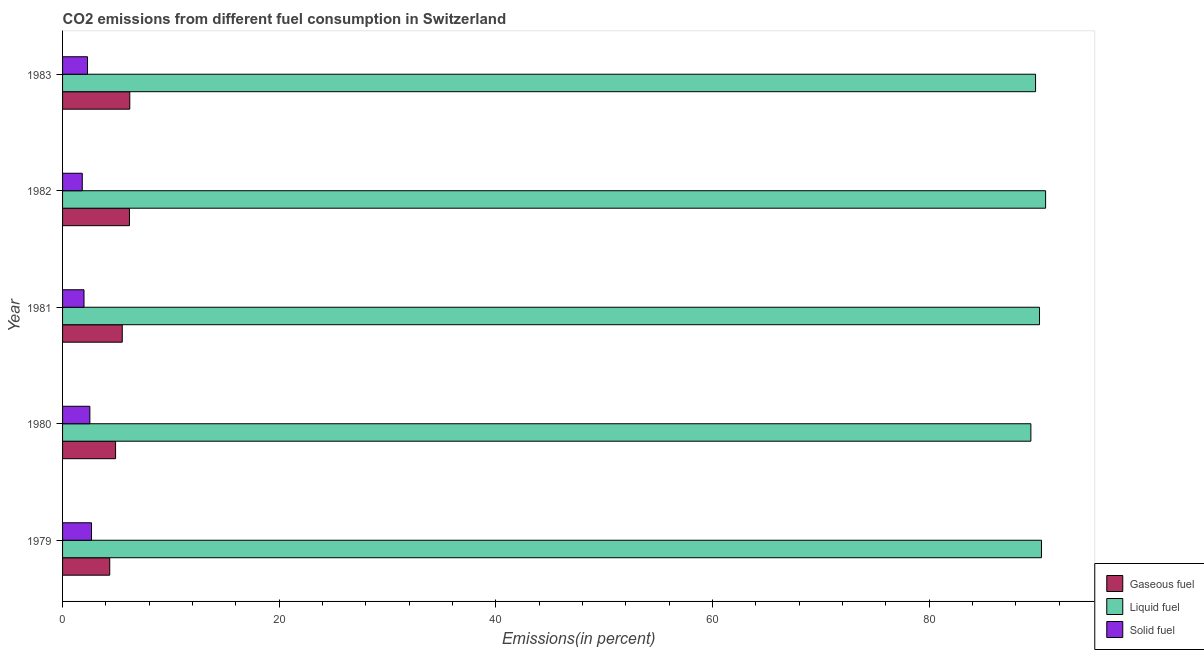Are the number of bars per tick equal to the number of legend labels?
Offer a very short reply. Yes. Are the number of bars on each tick of the Y-axis equal?
Keep it short and to the point. Yes. How many bars are there on the 1st tick from the top?
Ensure brevity in your answer.  3. What is the label of the 2nd group of bars from the top?
Provide a succinct answer. 1982. In how many cases, is the number of bars for a given year not equal to the number of legend labels?
Ensure brevity in your answer.  0. What is the percentage of gaseous fuel emission in 1979?
Your answer should be very brief. 4.36. Across all years, what is the maximum percentage of solid fuel emission?
Provide a short and direct response. 2.67. Across all years, what is the minimum percentage of solid fuel emission?
Provide a short and direct response. 1.82. In which year was the percentage of solid fuel emission maximum?
Your answer should be very brief. 1979. In which year was the percentage of gaseous fuel emission minimum?
Your answer should be very brief. 1979. What is the total percentage of solid fuel emission in the graph?
Provide a succinct answer. 11.29. What is the difference between the percentage of gaseous fuel emission in 1979 and that in 1983?
Give a very brief answer. -1.85. What is the difference between the percentage of liquid fuel emission in 1982 and the percentage of gaseous fuel emission in 1981?
Provide a succinct answer. 85.24. What is the average percentage of liquid fuel emission per year?
Offer a terse response. 90.11. In the year 1982, what is the difference between the percentage of liquid fuel emission and percentage of gaseous fuel emission?
Ensure brevity in your answer.  84.58. In how many years, is the percentage of gaseous fuel emission greater than 88 %?
Your answer should be very brief. 0. Is the difference between the percentage of gaseous fuel emission in 1981 and 1982 greater than the difference between the percentage of liquid fuel emission in 1981 and 1982?
Your response must be concise. No. What is the difference between the highest and the second highest percentage of gaseous fuel emission?
Offer a very short reply. 0.03. What is the difference between the highest and the lowest percentage of gaseous fuel emission?
Give a very brief answer. 1.85. Is the sum of the percentage of liquid fuel emission in 1981 and 1983 greater than the maximum percentage of solid fuel emission across all years?
Offer a terse response. Yes. What does the 1st bar from the top in 1983 represents?
Provide a succinct answer. Solid fuel. What does the 3rd bar from the bottom in 1983 represents?
Provide a short and direct response. Solid fuel. Is it the case that in every year, the sum of the percentage of gaseous fuel emission and percentage of liquid fuel emission is greater than the percentage of solid fuel emission?
Offer a very short reply. Yes. How many bars are there?
Provide a short and direct response. 15. Are all the bars in the graph horizontal?
Offer a very short reply. Yes. Does the graph contain grids?
Provide a succinct answer. No. How many legend labels are there?
Give a very brief answer. 3. What is the title of the graph?
Make the answer very short. CO2 emissions from different fuel consumption in Switzerland. What is the label or title of the X-axis?
Provide a short and direct response. Emissions(in percent). What is the Emissions(in percent) in Gaseous fuel in 1979?
Your answer should be compact. 4.36. What is the Emissions(in percent) in Liquid fuel in 1979?
Your answer should be compact. 90.37. What is the Emissions(in percent) in Solid fuel in 1979?
Your response must be concise. 2.67. What is the Emissions(in percent) of Gaseous fuel in 1980?
Provide a succinct answer. 4.89. What is the Emissions(in percent) in Liquid fuel in 1980?
Make the answer very short. 89.39. What is the Emissions(in percent) in Solid fuel in 1980?
Your response must be concise. 2.52. What is the Emissions(in percent) of Gaseous fuel in 1981?
Provide a succinct answer. 5.51. What is the Emissions(in percent) in Liquid fuel in 1981?
Give a very brief answer. 90.19. What is the Emissions(in percent) of Solid fuel in 1981?
Ensure brevity in your answer.  1.98. What is the Emissions(in percent) in Gaseous fuel in 1982?
Offer a terse response. 6.18. What is the Emissions(in percent) of Liquid fuel in 1982?
Ensure brevity in your answer.  90.75. What is the Emissions(in percent) in Solid fuel in 1982?
Provide a short and direct response. 1.82. What is the Emissions(in percent) in Gaseous fuel in 1983?
Your answer should be compact. 6.2. What is the Emissions(in percent) of Liquid fuel in 1983?
Your answer should be very brief. 89.83. What is the Emissions(in percent) of Solid fuel in 1983?
Keep it short and to the point. 2.3. Across all years, what is the maximum Emissions(in percent) of Gaseous fuel?
Offer a very short reply. 6.2. Across all years, what is the maximum Emissions(in percent) in Liquid fuel?
Provide a short and direct response. 90.75. Across all years, what is the maximum Emissions(in percent) in Solid fuel?
Offer a terse response. 2.67. Across all years, what is the minimum Emissions(in percent) of Gaseous fuel?
Keep it short and to the point. 4.36. Across all years, what is the minimum Emissions(in percent) in Liquid fuel?
Provide a succinct answer. 89.39. Across all years, what is the minimum Emissions(in percent) of Solid fuel?
Provide a succinct answer. 1.82. What is the total Emissions(in percent) in Gaseous fuel in the graph?
Give a very brief answer. 27.14. What is the total Emissions(in percent) in Liquid fuel in the graph?
Ensure brevity in your answer.  450.53. What is the total Emissions(in percent) in Solid fuel in the graph?
Offer a very short reply. 11.29. What is the difference between the Emissions(in percent) in Gaseous fuel in 1979 and that in 1980?
Offer a terse response. -0.54. What is the difference between the Emissions(in percent) in Liquid fuel in 1979 and that in 1980?
Provide a succinct answer. 0.98. What is the difference between the Emissions(in percent) of Solid fuel in 1979 and that in 1980?
Keep it short and to the point. 0.15. What is the difference between the Emissions(in percent) of Gaseous fuel in 1979 and that in 1981?
Your answer should be very brief. -1.16. What is the difference between the Emissions(in percent) in Liquid fuel in 1979 and that in 1981?
Offer a very short reply. 0.18. What is the difference between the Emissions(in percent) of Solid fuel in 1979 and that in 1981?
Provide a short and direct response. 0.69. What is the difference between the Emissions(in percent) of Gaseous fuel in 1979 and that in 1982?
Make the answer very short. -1.82. What is the difference between the Emissions(in percent) in Liquid fuel in 1979 and that in 1982?
Offer a terse response. -0.38. What is the difference between the Emissions(in percent) in Solid fuel in 1979 and that in 1982?
Ensure brevity in your answer.  0.85. What is the difference between the Emissions(in percent) of Gaseous fuel in 1979 and that in 1983?
Provide a short and direct response. -1.85. What is the difference between the Emissions(in percent) of Liquid fuel in 1979 and that in 1983?
Your response must be concise. 0.54. What is the difference between the Emissions(in percent) of Solid fuel in 1979 and that in 1983?
Ensure brevity in your answer.  0.37. What is the difference between the Emissions(in percent) in Gaseous fuel in 1980 and that in 1981?
Your answer should be very brief. -0.62. What is the difference between the Emissions(in percent) in Liquid fuel in 1980 and that in 1981?
Your answer should be compact. -0.8. What is the difference between the Emissions(in percent) of Solid fuel in 1980 and that in 1981?
Keep it short and to the point. 0.54. What is the difference between the Emissions(in percent) in Gaseous fuel in 1980 and that in 1982?
Offer a very short reply. -1.28. What is the difference between the Emissions(in percent) of Liquid fuel in 1980 and that in 1982?
Keep it short and to the point. -1.36. What is the difference between the Emissions(in percent) of Solid fuel in 1980 and that in 1982?
Offer a very short reply. 0.7. What is the difference between the Emissions(in percent) in Gaseous fuel in 1980 and that in 1983?
Your answer should be compact. -1.31. What is the difference between the Emissions(in percent) in Liquid fuel in 1980 and that in 1983?
Offer a terse response. -0.43. What is the difference between the Emissions(in percent) in Solid fuel in 1980 and that in 1983?
Your answer should be compact. 0.22. What is the difference between the Emissions(in percent) of Gaseous fuel in 1981 and that in 1982?
Make the answer very short. -0.67. What is the difference between the Emissions(in percent) in Liquid fuel in 1981 and that in 1982?
Provide a succinct answer. -0.56. What is the difference between the Emissions(in percent) in Solid fuel in 1981 and that in 1982?
Offer a terse response. 0.16. What is the difference between the Emissions(in percent) of Gaseous fuel in 1981 and that in 1983?
Your answer should be very brief. -0.69. What is the difference between the Emissions(in percent) of Liquid fuel in 1981 and that in 1983?
Your answer should be very brief. 0.36. What is the difference between the Emissions(in percent) of Solid fuel in 1981 and that in 1983?
Your answer should be compact. -0.32. What is the difference between the Emissions(in percent) in Gaseous fuel in 1982 and that in 1983?
Give a very brief answer. -0.03. What is the difference between the Emissions(in percent) of Liquid fuel in 1982 and that in 1983?
Keep it short and to the point. 0.93. What is the difference between the Emissions(in percent) of Solid fuel in 1982 and that in 1983?
Offer a terse response. -0.48. What is the difference between the Emissions(in percent) in Gaseous fuel in 1979 and the Emissions(in percent) in Liquid fuel in 1980?
Give a very brief answer. -85.04. What is the difference between the Emissions(in percent) of Gaseous fuel in 1979 and the Emissions(in percent) of Solid fuel in 1980?
Ensure brevity in your answer.  1.84. What is the difference between the Emissions(in percent) of Liquid fuel in 1979 and the Emissions(in percent) of Solid fuel in 1980?
Offer a very short reply. 87.85. What is the difference between the Emissions(in percent) in Gaseous fuel in 1979 and the Emissions(in percent) in Liquid fuel in 1981?
Your response must be concise. -85.83. What is the difference between the Emissions(in percent) in Gaseous fuel in 1979 and the Emissions(in percent) in Solid fuel in 1981?
Your response must be concise. 2.38. What is the difference between the Emissions(in percent) of Liquid fuel in 1979 and the Emissions(in percent) of Solid fuel in 1981?
Ensure brevity in your answer.  88.39. What is the difference between the Emissions(in percent) in Gaseous fuel in 1979 and the Emissions(in percent) in Liquid fuel in 1982?
Provide a succinct answer. -86.4. What is the difference between the Emissions(in percent) of Gaseous fuel in 1979 and the Emissions(in percent) of Solid fuel in 1982?
Ensure brevity in your answer.  2.53. What is the difference between the Emissions(in percent) in Liquid fuel in 1979 and the Emissions(in percent) in Solid fuel in 1982?
Make the answer very short. 88.55. What is the difference between the Emissions(in percent) in Gaseous fuel in 1979 and the Emissions(in percent) in Liquid fuel in 1983?
Provide a succinct answer. -85.47. What is the difference between the Emissions(in percent) of Gaseous fuel in 1979 and the Emissions(in percent) of Solid fuel in 1983?
Offer a terse response. 2.05. What is the difference between the Emissions(in percent) of Liquid fuel in 1979 and the Emissions(in percent) of Solid fuel in 1983?
Provide a short and direct response. 88.07. What is the difference between the Emissions(in percent) of Gaseous fuel in 1980 and the Emissions(in percent) of Liquid fuel in 1981?
Offer a very short reply. -85.3. What is the difference between the Emissions(in percent) in Gaseous fuel in 1980 and the Emissions(in percent) in Solid fuel in 1981?
Your answer should be very brief. 2.91. What is the difference between the Emissions(in percent) in Liquid fuel in 1980 and the Emissions(in percent) in Solid fuel in 1981?
Keep it short and to the point. 87.41. What is the difference between the Emissions(in percent) in Gaseous fuel in 1980 and the Emissions(in percent) in Liquid fuel in 1982?
Provide a succinct answer. -85.86. What is the difference between the Emissions(in percent) in Gaseous fuel in 1980 and the Emissions(in percent) in Solid fuel in 1982?
Provide a succinct answer. 3.07. What is the difference between the Emissions(in percent) in Liquid fuel in 1980 and the Emissions(in percent) in Solid fuel in 1982?
Offer a terse response. 87.57. What is the difference between the Emissions(in percent) of Gaseous fuel in 1980 and the Emissions(in percent) of Liquid fuel in 1983?
Keep it short and to the point. -84.93. What is the difference between the Emissions(in percent) in Gaseous fuel in 1980 and the Emissions(in percent) in Solid fuel in 1983?
Offer a very short reply. 2.59. What is the difference between the Emissions(in percent) of Liquid fuel in 1980 and the Emissions(in percent) of Solid fuel in 1983?
Provide a succinct answer. 87.09. What is the difference between the Emissions(in percent) of Gaseous fuel in 1981 and the Emissions(in percent) of Liquid fuel in 1982?
Provide a short and direct response. -85.24. What is the difference between the Emissions(in percent) in Gaseous fuel in 1981 and the Emissions(in percent) in Solid fuel in 1982?
Your response must be concise. 3.69. What is the difference between the Emissions(in percent) in Liquid fuel in 1981 and the Emissions(in percent) in Solid fuel in 1982?
Keep it short and to the point. 88.37. What is the difference between the Emissions(in percent) in Gaseous fuel in 1981 and the Emissions(in percent) in Liquid fuel in 1983?
Your response must be concise. -84.31. What is the difference between the Emissions(in percent) in Gaseous fuel in 1981 and the Emissions(in percent) in Solid fuel in 1983?
Your response must be concise. 3.21. What is the difference between the Emissions(in percent) of Liquid fuel in 1981 and the Emissions(in percent) of Solid fuel in 1983?
Give a very brief answer. 87.89. What is the difference between the Emissions(in percent) of Gaseous fuel in 1982 and the Emissions(in percent) of Liquid fuel in 1983?
Provide a succinct answer. -83.65. What is the difference between the Emissions(in percent) in Gaseous fuel in 1982 and the Emissions(in percent) in Solid fuel in 1983?
Offer a very short reply. 3.87. What is the difference between the Emissions(in percent) of Liquid fuel in 1982 and the Emissions(in percent) of Solid fuel in 1983?
Keep it short and to the point. 88.45. What is the average Emissions(in percent) in Gaseous fuel per year?
Provide a short and direct response. 5.43. What is the average Emissions(in percent) of Liquid fuel per year?
Provide a short and direct response. 90.11. What is the average Emissions(in percent) in Solid fuel per year?
Your answer should be compact. 2.26. In the year 1979, what is the difference between the Emissions(in percent) in Gaseous fuel and Emissions(in percent) in Liquid fuel?
Provide a short and direct response. -86.01. In the year 1979, what is the difference between the Emissions(in percent) of Gaseous fuel and Emissions(in percent) of Solid fuel?
Provide a short and direct response. 1.68. In the year 1979, what is the difference between the Emissions(in percent) of Liquid fuel and Emissions(in percent) of Solid fuel?
Provide a short and direct response. 87.7. In the year 1980, what is the difference between the Emissions(in percent) in Gaseous fuel and Emissions(in percent) in Liquid fuel?
Your answer should be very brief. -84.5. In the year 1980, what is the difference between the Emissions(in percent) in Gaseous fuel and Emissions(in percent) in Solid fuel?
Make the answer very short. 2.37. In the year 1980, what is the difference between the Emissions(in percent) of Liquid fuel and Emissions(in percent) of Solid fuel?
Your response must be concise. 86.87. In the year 1981, what is the difference between the Emissions(in percent) of Gaseous fuel and Emissions(in percent) of Liquid fuel?
Offer a terse response. -84.68. In the year 1981, what is the difference between the Emissions(in percent) of Gaseous fuel and Emissions(in percent) of Solid fuel?
Give a very brief answer. 3.53. In the year 1981, what is the difference between the Emissions(in percent) in Liquid fuel and Emissions(in percent) in Solid fuel?
Make the answer very short. 88.21. In the year 1982, what is the difference between the Emissions(in percent) of Gaseous fuel and Emissions(in percent) of Liquid fuel?
Provide a succinct answer. -84.58. In the year 1982, what is the difference between the Emissions(in percent) of Gaseous fuel and Emissions(in percent) of Solid fuel?
Your answer should be very brief. 4.36. In the year 1982, what is the difference between the Emissions(in percent) in Liquid fuel and Emissions(in percent) in Solid fuel?
Provide a short and direct response. 88.93. In the year 1983, what is the difference between the Emissions(in percent) in Gaseous fuel and Emissions(in percent) in Liquid fuel?
Your answer should be very brief. -83.62. In the year 1983, what is the difference between the Emissions(in percent) of Gaseous fuel and Emissions(in percent) of Solid fuel?
Your response must be concise. 3.9. In the year 1983, what is the difference between the Emissions(in percent) of Liquid fuel and Emissions(in percent) of Solid fuel?
Give a very brief answer. 87.52. What is the ratio of the Emissions(in percent) of Gaseous fuel in 1979 to that in 1980?
Your response must be concise. 0.89. What is the ratio of the Emissions(in percent) in Liquid fuel in 1979 to that in 1980?
Your answer should be very brief. 1.01. What is the ratio of the Emissions(in percent) of Solid fuel in 1979 to that in 1980?
Provide a succinct answer. 1.06. What is the ratio of the Emissions(in percent) of Gaseous fuel in 1979 to that in 1981?
Provide a short and direct response. 0.79. What is the ratio of the Emissions(in percent) of Solid fuel in 1979 to that in 1981?
Your response must be concise. 1.35. What is the ratio of the Emissions(in percent) in Gaseous fuel in 1979 to that in 1982?
Make the answer very short. 0.71. What is the ratio of the Emissions(in percent) of Liquid fuel in 1979 to that in 1982?
Offer a very short reply. 1. What is the ratio of the Emissions(in percent) in Solid fuel in 1979 to that in 1982?
Offer a very short reply. 1.47. What is the ratio of the Emissions(in percent) of Gaseous fuel in 1979 to that in 1983?
Make the answer very short. 0.7. What is the ratio of the Emissions(in percent) in Liquid fuel in 1979 to that in 1983?
Your answer should be very brief. 1.01. What is the ratio of the Emissions(in percent) of Solid fuel in 1979 to that in 1983?
Keep it short and to the point. 1.16. What is the ratio of the Emissions(in percent) of Gaseous fuel in 1980 to that in 1981?
Make the answer very short. 0.89. What is the ratio of the Emissions(in percent) of Solid fuel in 1980 to that in 1981?
Make the answer very short. 1.27. What is the ratio of the Emissions(in percent) in Gaseous fuel in 1980 to that in 1982?
Provide a short and direct response. 0.79. What is the ratio of the Emissions(in percent) in Liquid fuel in 1980 to that in 1982?
Ensure brevity in your answer.  0.98. What is the ratio of the Emissions(in percent) of Solid fuel in 1980 to that in 1982?
Make the answer very short. 1.38. What is the ratio of the Emissions(in percent) in Gaseous fuel in 1980 to that in 1983?
Make the answer very short. 0.79. What is the ratio of the Emissions(in percent) in Liquid fuel in 1980 to that in 1983?
Your response must be concise. 1. What is the ratio of the Emissions(in percent) of Solid fuel in 1980 to that in 1983?
Offer a very short reply. 1.09. What is the ratio of the Emissions(in percent) in Gaseous fuel in 1981 to that in 1982?
Your response must be concise. 0.89. What is the ratio of the Emissions(in percent) in Liquid fuel in 1981 to that in 1982?
Keep it short and to the point. 0.99. What is the ratio of the Emissions(in percent) of Solid fuel in 1981 to that in 1982?
Your answer should be very brief. 1.09. What is the ratio of the Emissions(in percent) in Gaseous fuel in 1981 to that in 1983?
Make the answer very short. 0.89. What is the ratio of the Emissions(in percent) in Solid fuel in 1981 to that in 1983?
Your answer should be compact. 0.86. What is the ratio of the Emissions(in percent) of Gaseous fuel in 1982 to that in 1983?
Provide a succinct answer. 1. What is the ratio of the Emissions(in percent) of Liquid fuel in 1982 to that in 1983?
Your answer should be very brief. 1.01. What is the ratio of the Emissions(in percent) in Solid fuel in 1982 to that in 1983?
Provide a succinct answer. 0.79. What is the difference between the highest and the second highest Emissions(in percent) of Gaseous fuel?
Make the answer very short. 0.03. What is the difference between the highest and the second highest Emissions(in percent) of Liquid fuel?
Ensure brevity in your answer.  0.38. What is the difference between the highest and the second highest Emissions(in percent) of Solid fuel?
Your answer should be very brief. 0.15. What is the difference between the highest and the lowest Emissions(in percent) of Gaseous fuel?
Your response must be concise. 1.85. What is the difference between the highest and the lowest Emissions(in percent) of Liquid fuel?
Provide a short and direct response. 1.36. What is the difference between the highest and the lowest Emissions(in percent) in Solid fuel?
Your answer should be very brief. 0.85. 